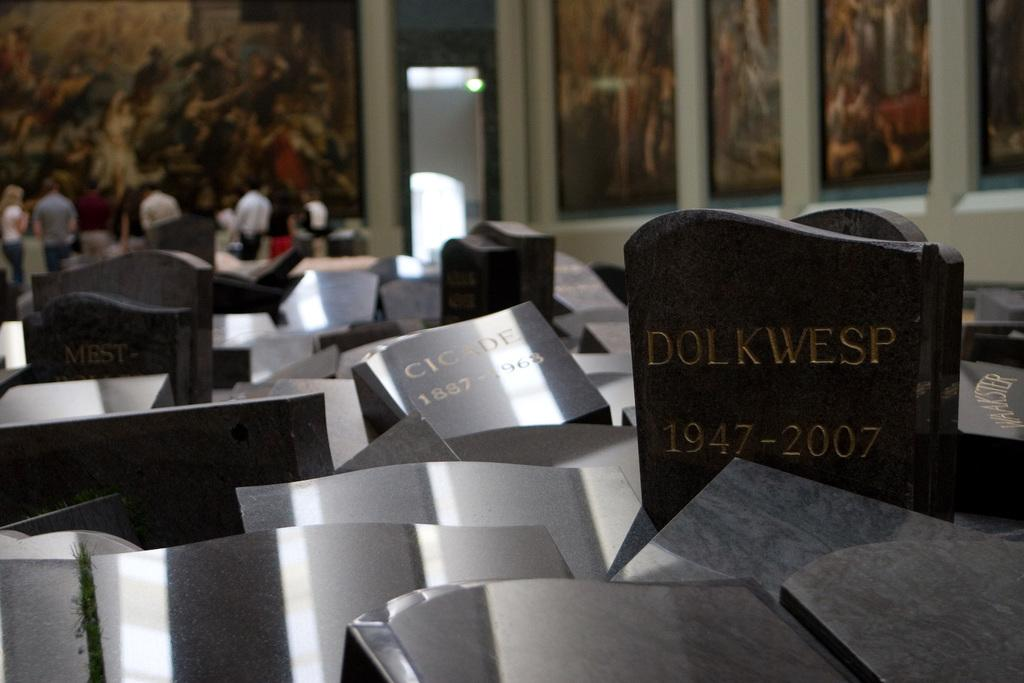What type of objects can be seen in the image? There are tombstones in the image. Are there any people present in the image? Yes, there are people in the image. What can be found on the tombstones? There is writing on the tombstones. How would you describe the background of the image? The background is blurred. Where is the hidden cellar located in the image? There is no mention of a cellar in the image, so its location cannot be determined. What type of growth can be seen on the tombstones in the image? There is no growth visible on the tombstones in the image. 